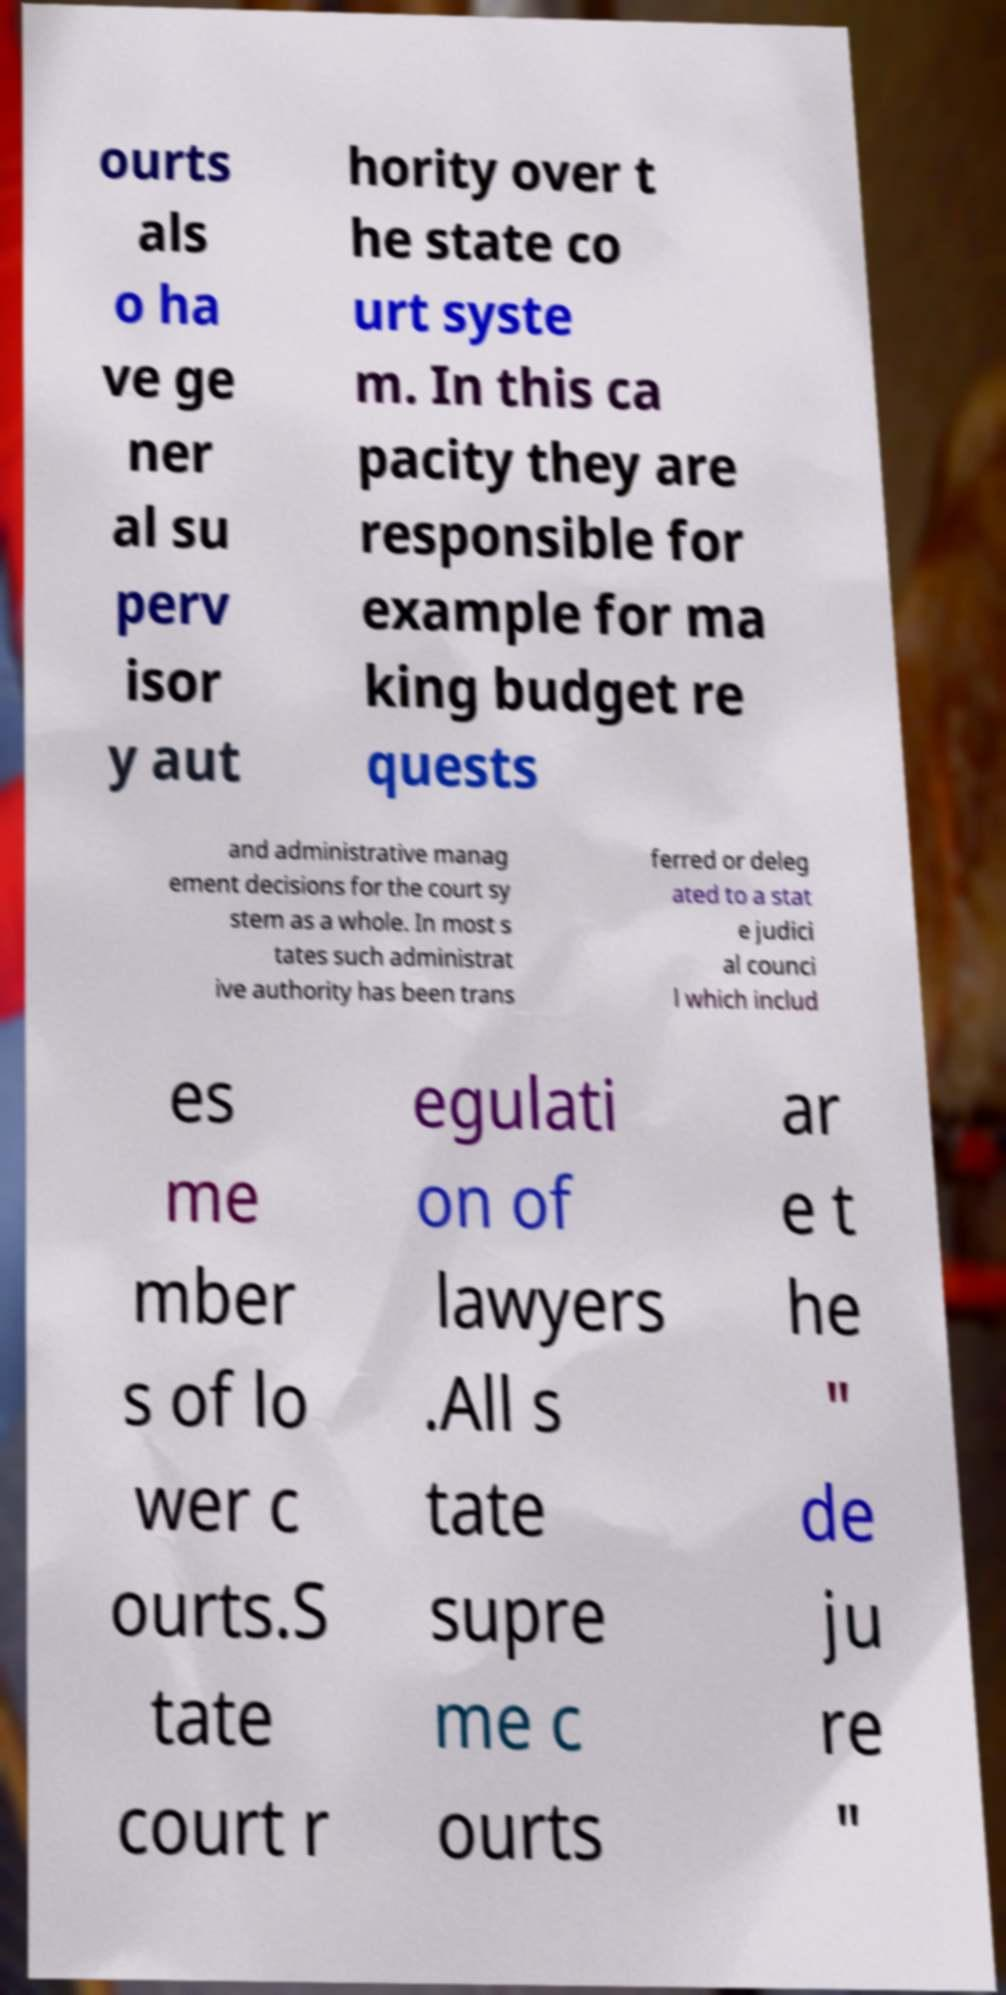Can you accurately transcribe the text from the provided image for me? ourts als o ha ve ge ner al su perv isor y aut hority over t he state co urt syste m. In this ca pacity they are responsible for example for ma king budget re quests and administrative manag ement decisions for the court sy stem as a whole. In most s tates such administrat ive authority has been trans ferred or deleg ated to a stat e judici al counci l which includ es me mber s of lo wer c ourts.S tate court r egulati on of lawyers .All s tate supre me c ourts ar e t he " de ju re " 